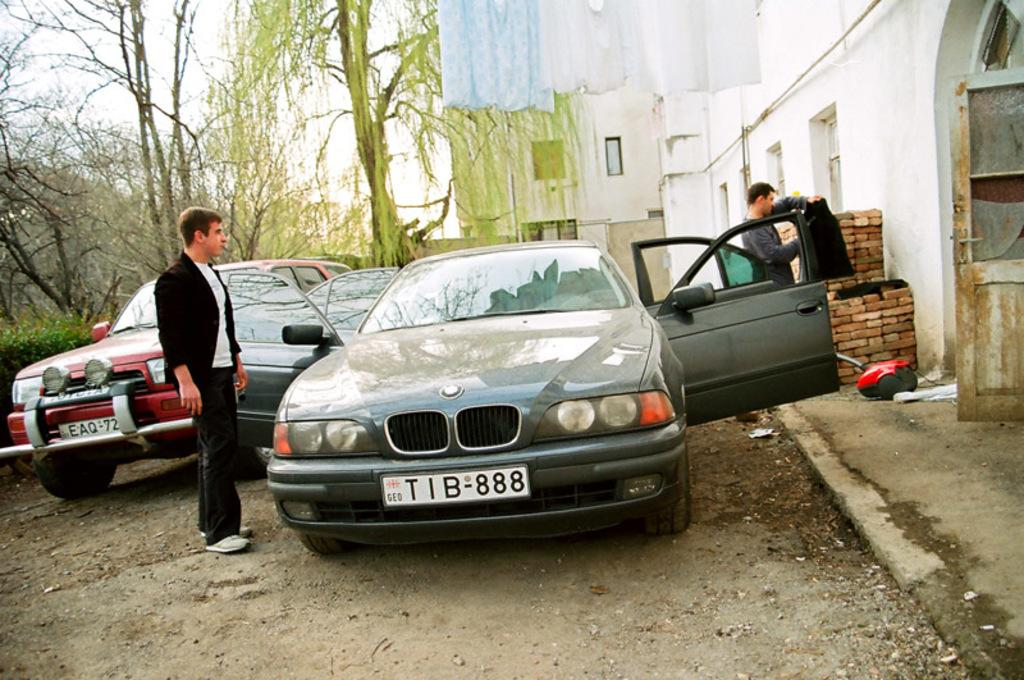What is located on the left side of the image? There is a man standing on the left side of the image. What is the man wearing? The man is wearing a black coat. What can be seen in the middle of the image? There is a car in the middle of the image. What is visible in the background of the image? There are trees in the background of the image. How many books can be seen on the man's head in the image? There are no books visible in the image; the man is wearing a black coat. What type of stretch is the man performing in the image? There is no indication of the man performing any stretch in the image; he is simply standing on the left side. 